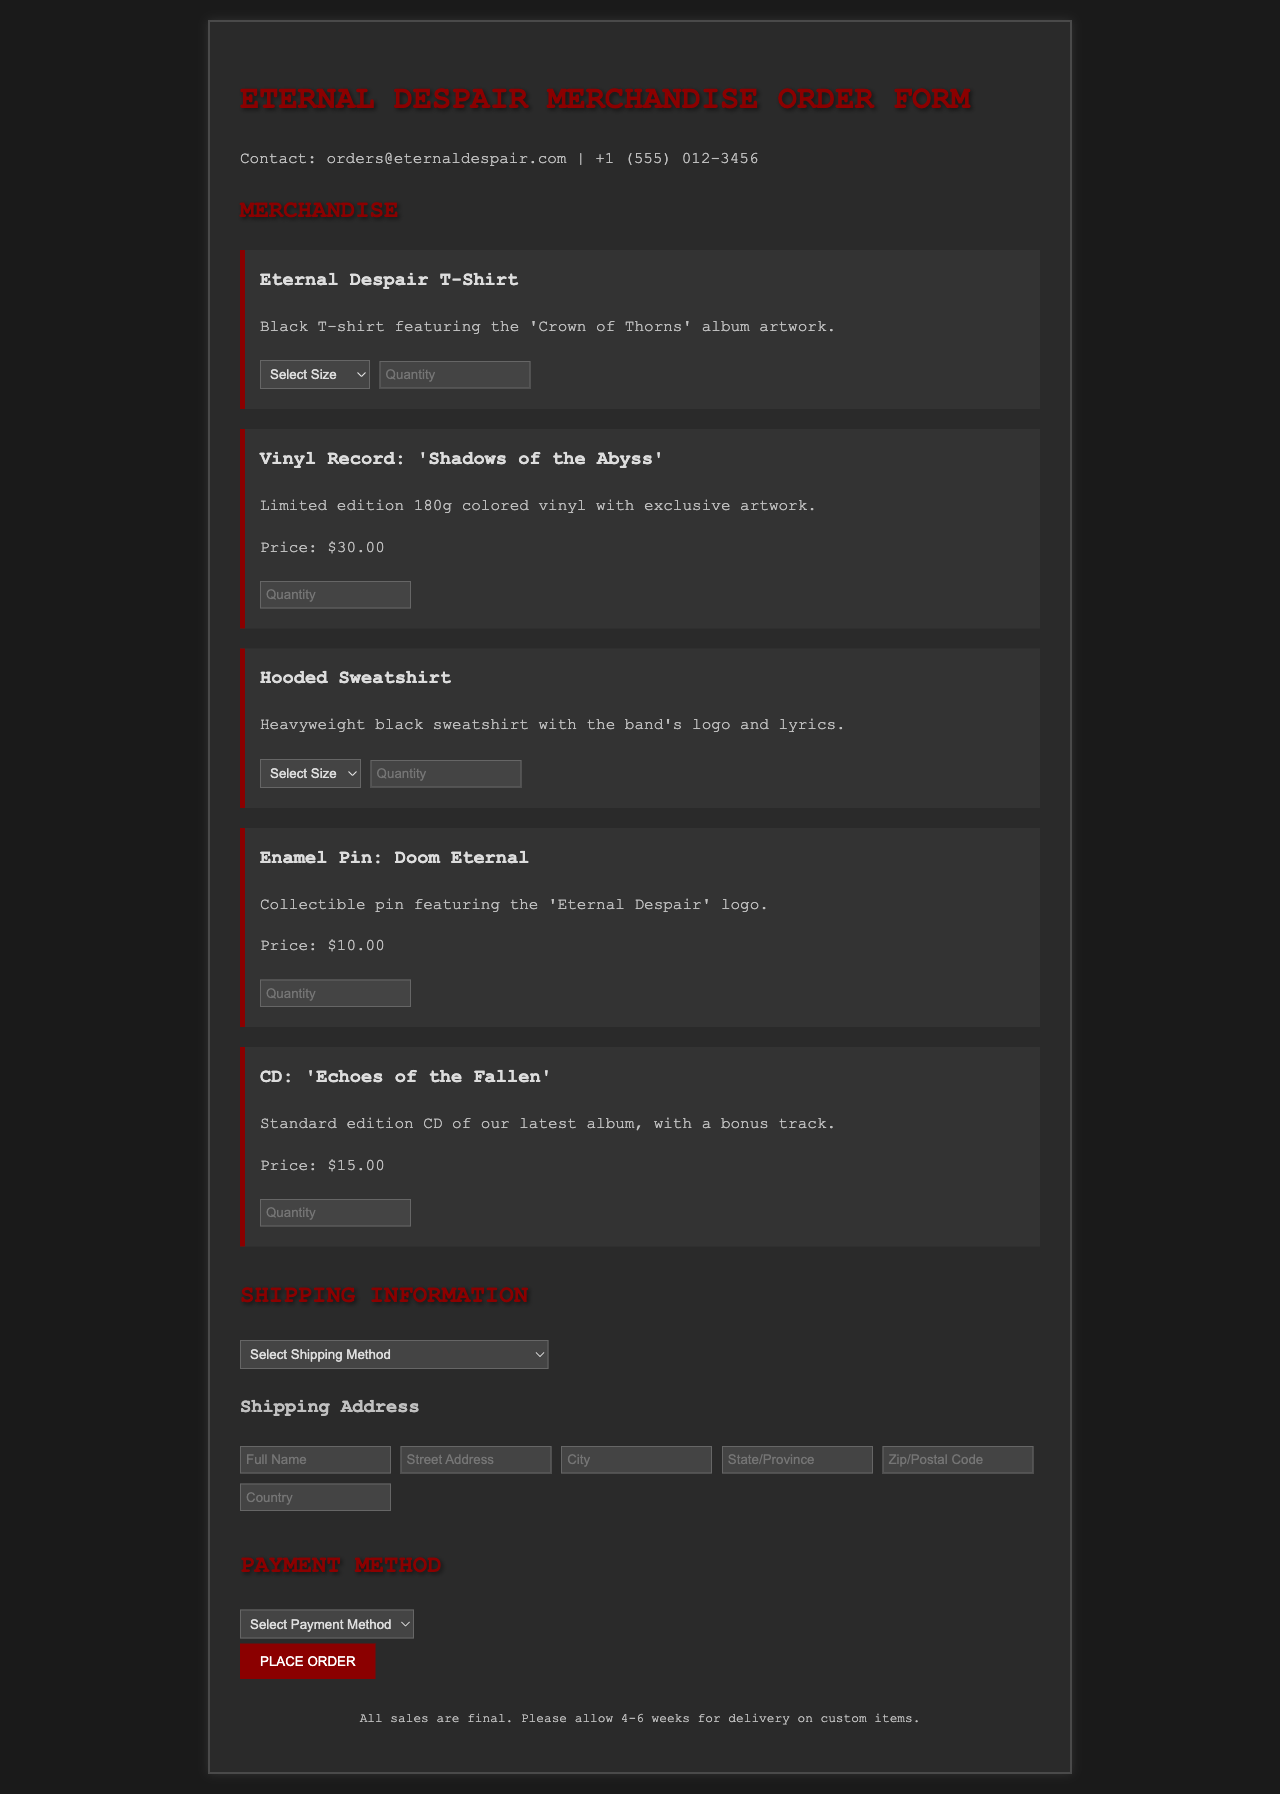What is the email contact for orders? The email contact is provided in the document under the contact section.
Answer: orders@eternaldespair.com What is the price of the vinyl record 'Shadows of the Abyss'? The price for the vinyl record is stated in the item description.
Answer: $30.00 How many business days does standard shipping take? The shipping method description includes the delivery timeframe for standard shipping.
Answer: 5-7 business days What is the size option for the hooded sweatshirt? The size options are listed under the hooded sweatshirt section in a select dropdown.
Answer: S, M, L, XL What is the price of the enamel pin? The document explicitly states the price of the enamel pin in its description.
Answer: $10.00 What payment methods are available? The payment section outlines the various accepted payment methods.
Answer: Credit Card, PayPal, Venmo How much does express shipping cost? The shipping method descriptions in the document provide this cost.
Answer: $15.00 What is the required information for shipping address? The form outlines the necessary fields for a complete shipping address.
Answer: Full Name, Street Address, City, State/Province, Zip/Postal Code, Country What is the maximum quantity you can order for any item? The quantity input fields specify the minimum, but not the maximum order limit, making this a reasoning-based question.
Answer: No specified limit 